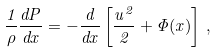<formula> <loc_0><loc_0><loc_500><loc_500>\frac { 1 } { \rho } \frac { d P } { d x } = - \frac { d } { d x } \left [ \frac { u ^ { 2 } } { 2 } + \Phi ( x ) \right ] \, ,</formula> 